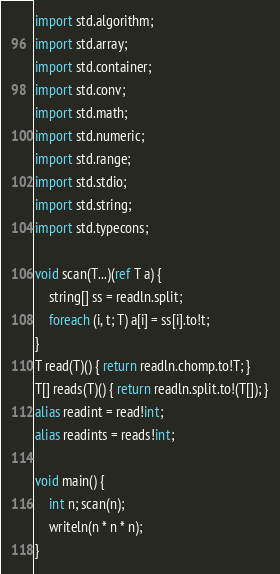Convert code to text. <code><loc_0><loc_0><loc_500><loc_500><_D_>import std.algorithm;
import std.array;
import std.container;
import std.conv;
import std.math;
import std.numeric;
import std.range;
import std.stdio;
import std.string;
import std.typecons;

void scan(T...)(ref T a) {
    string[] ss = readln.split;
    foreach (i, t; T) a[i] = ss[i].to!t;
}
T read(T)() { return readln.chomp.to!T; }
T[] reads(T)() { return readln.split.to!(T[]); }
alias readint = read!int;
alias readints = reads!int;

void main() {
    int n; scan(n);
    writeln(n * n * n);
}
</code> 